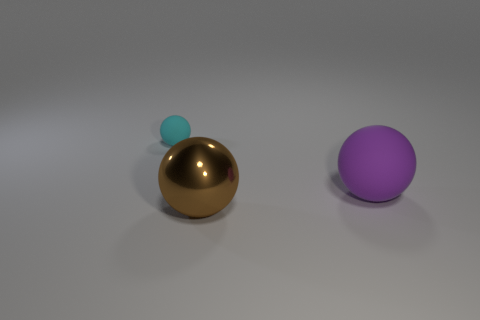Do the big sphere that is in front of the big matte ball and the tiny thing have the same material?
Give a very brief answer. No. Is there anything else that is made of the same material as the purple object?
Make the answer very short. Yes. There is a rubber object that is behind the matte ball that is to the right of the cyan thing; how many big brown objects are on the left side of it?
Ensure brevity in your answer.  0. There is a thing on the left side of the large shiny thing; does it have the same shape as the large purple object?
Offer a terse response. Yes. What number of things are large gray metal blocks or things in front of the tiny matte object?
Your answer should be very brief. 2. Is the number of small balls that are on the right side of the tiny cyan rubber ball greater than the number of gray blocks?
Provide a short and direct response. No. Are there the same number of small cyan spheres that are to the right of the big shiny object and purple things in front of the large matte thing?
Provide a short and direct response. Yes. Is there a cyan matte ball on the right side of the matte ball on the left side of the large purple rubber sphere?
Your answer should be compact. No. The large brown metal thing has what shape?
Provide a succinct answer. Sphere. There is a thing in front of the big ball that is behind the large shiny object; what size is it?
Offer a terse response. Large. 